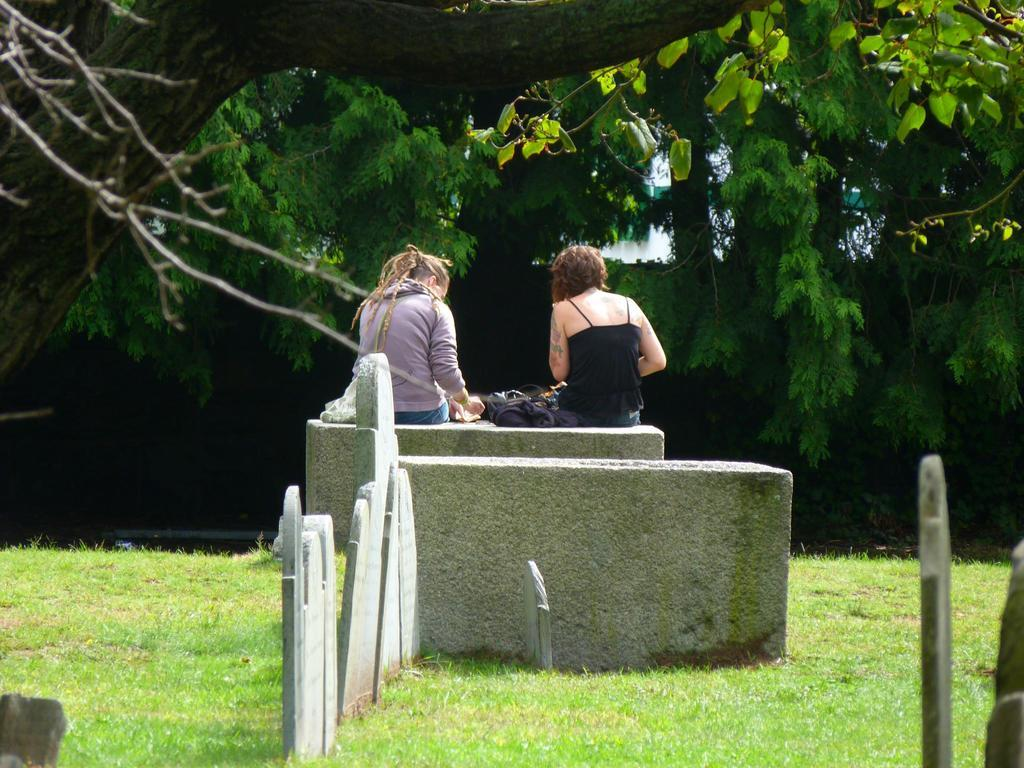What are the people in the image doing? The people in the image are sitting on a wall. What type of vegetation is at the bottom of the image? There is grass at the bottom of the image. What can be seen in the background of the image? There are trees in the background of the image. What type of material is present in the middle of the image? There are stones in the middle of the image. What type of headphones can be seen on the people in the image? There are no headphones visible on the people in the image. What type of system is being used by the people in the image? There is no system present in the image; the people are simply sitting on a wall. 